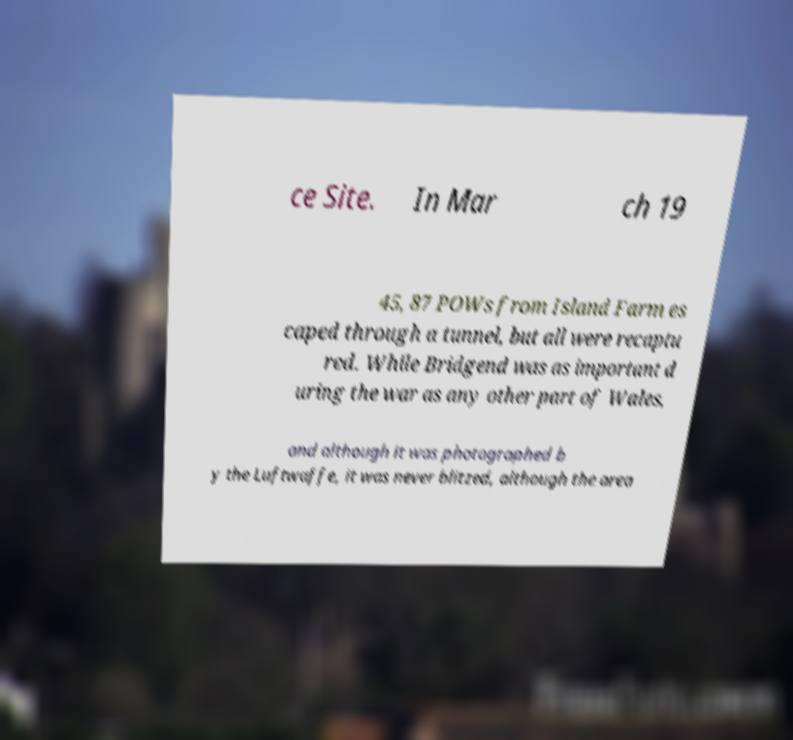What messages or text are displayed in this image? I need them in a readable, typed format. ce Site. In Mar ch 19 45, 87 POWs from Island Farm es caped through a tunnel, but all were recaptu red. While Bridgend was as important d uring the war as any other part of Wales, and although it was photographed b y the Luftwaffe, it was never blitzed, although the area 